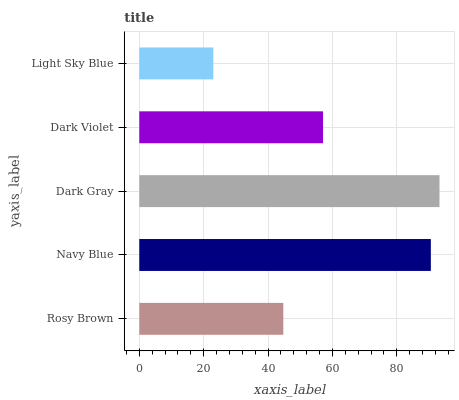Is Light Sky Blue the minimum?
Answer yes or no. Yes. Is Dark Gray the maximum?
Answer yes or no. Yes. Is Navy Blue the minimum?
Answer yes or no. No. Is Navy Blue the maximum?
Answer yes or no. No. Is Navy Blue greater than Rosy Brown?
Answer yes or no. Yes. Is Rosy Brown less than Navy Blue?
Answer yes or no. Yes. Is Rosy Brown greater than Navy Blue?
Answer yes or no. No. Is Navy Blue less than Rosy Brown?
Answer yes or no. No. Is Dark Violet the high median?
Answer yes or no. Yes. Is Dark Violet the low median?
Answer yes or no. Yes. Is Navy Blue the high median?
Answer yes or no. No. Is Light Sky Blue the low median?
Answer yes or no. No. 